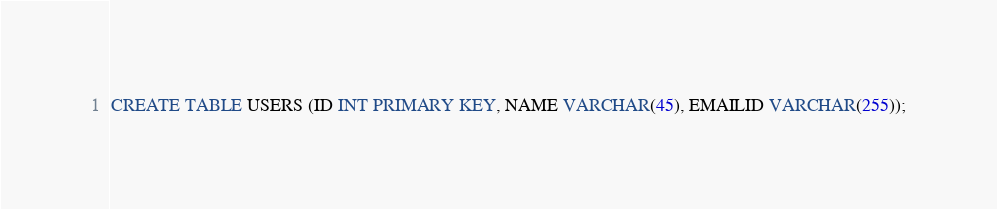Convert code to text. <code><loc_0><loc_0><loc_500><loc_500><_SQL_>CREATE TABLE USERS (ID INT PRIMARY KEY, NAME VARCHAR(45), EMAILID VARCHAR(255));</code> 